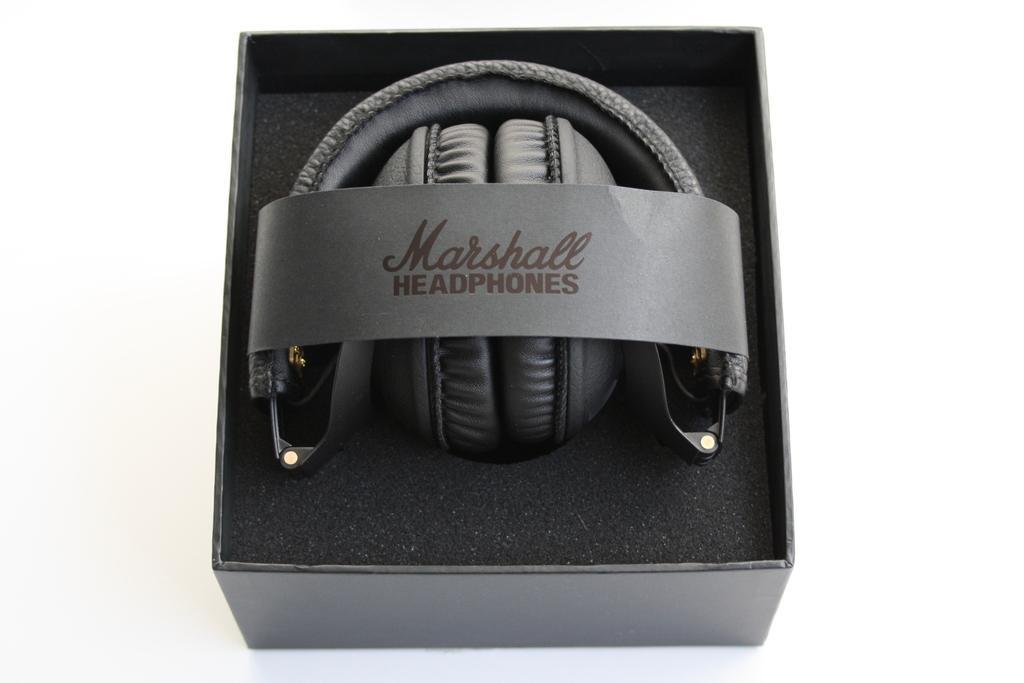Please provide a concise description of this image. In this image, we can see headsets in a box. Here we can see sponge and paper. On the paper, we can see some text. This box is placed on the white surface. 